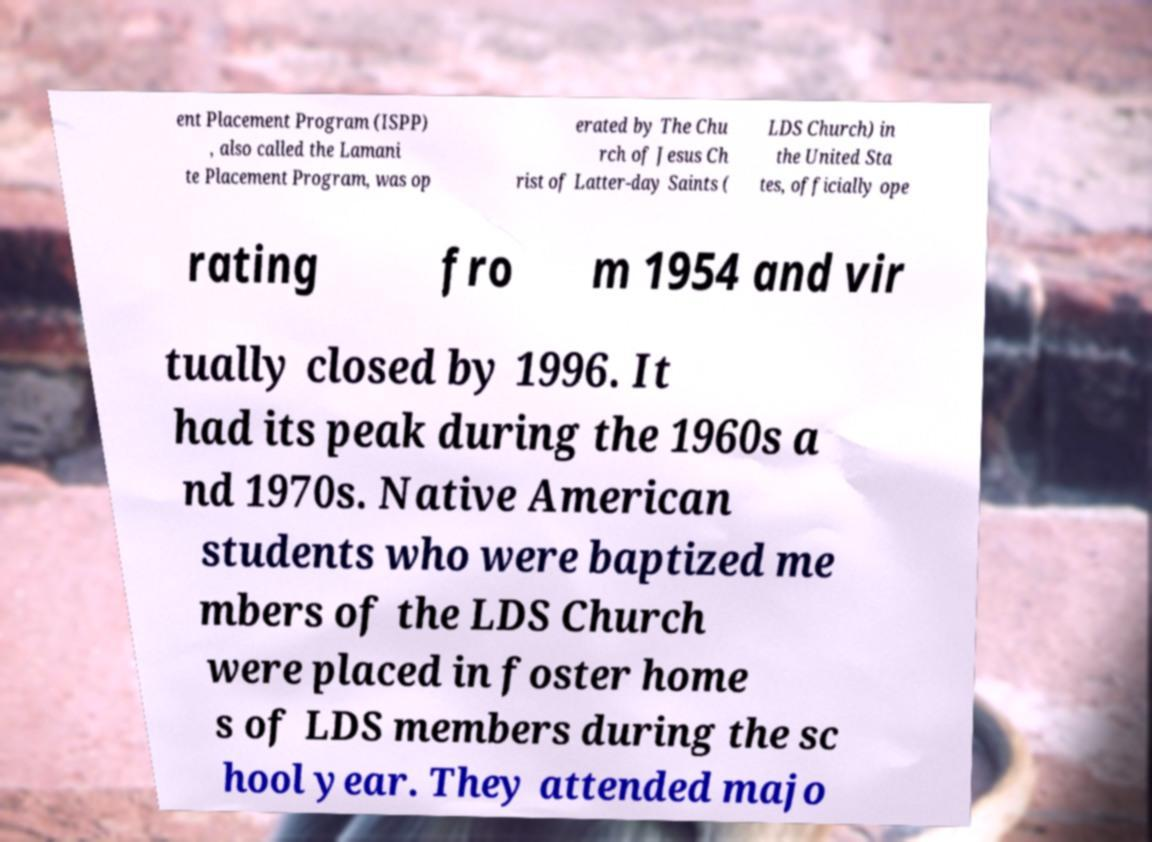Could you assist in decoding the text presented in this image and type it out clearly? ent Placement Program (ISPP) , also called the Lamani te Placement Program, was op erated by The Chu rch of Jesus Ch rist of Latter-day Saints ( LDS Church) in the United Sta tes, officially ope rating fro m 1954 and vir tually closed by 1996. It had its peak during the 1960s a nd 1970s. Native American students who were baptized me mbers of the LDS Church were placed in foster home s of LDS members during the sc hool year. They attended majo 